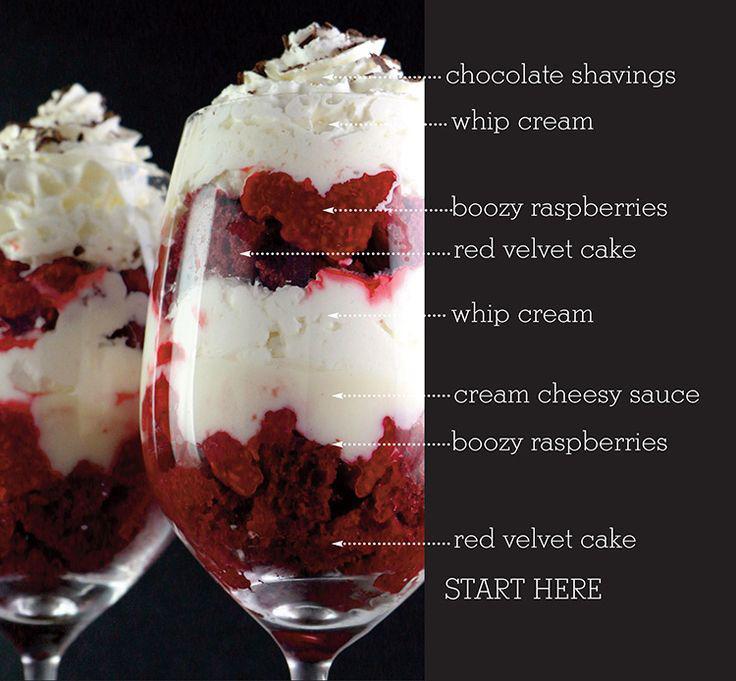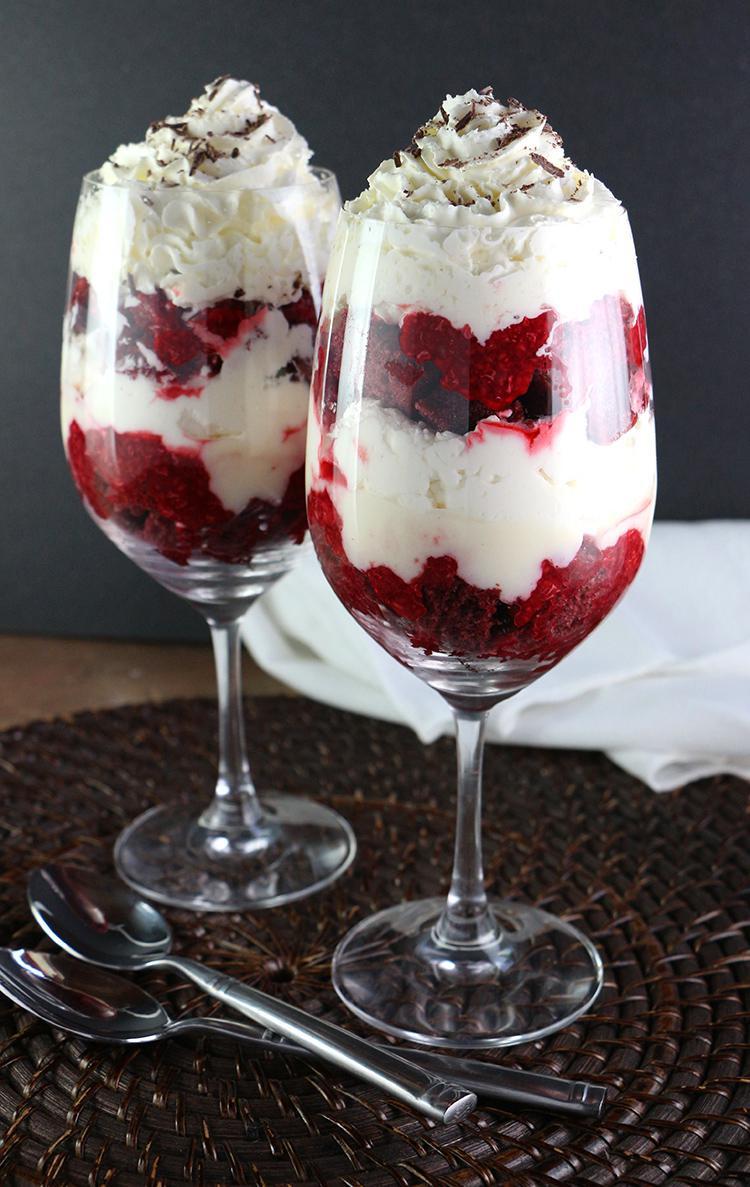The first image is the image on the left, the second image is the image on the right. Assess this claim about the two images: "Each dessert is being served in a large glass family sized portion.". Correct or not? Answer yes or no. No. The first image is the image on the left, the second image is the image on the right. Evaluate the accuracy of this statement regarding the images: "Whole red raspberries garnish the top of at least one layered dessert served in a clear glass dish.". Is it true? Answer yes or no. No. 